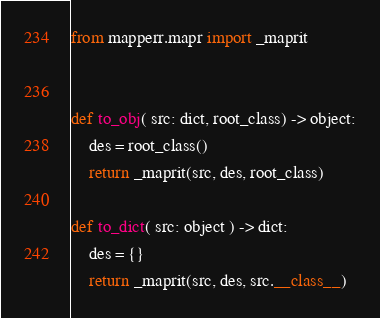Convert code to text. <code><loc_0><loc_0><loc_500><loc_500><_Python_>from mapperr.mapr import _maprit


def to_obj( src: dict, root_class) -> object:
    des = root_class()
    return _maprit(src, des, root_class)
                
def to_dict( src: object ) -> dict:
    des = {}
    return _maprit(src, des, src.__class__)
</code> 